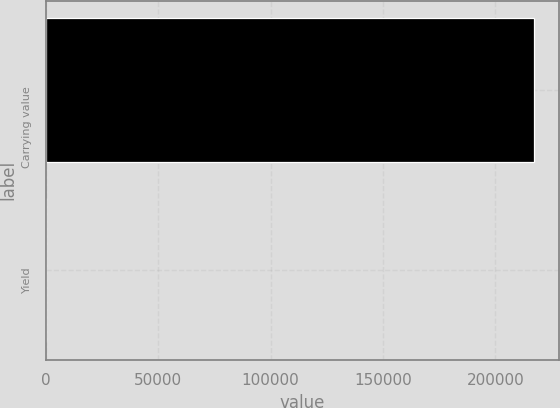Convert chart. <chart><loc_0><loc_0><loc_500><loc_500><bar_chart><fcel>Carrying value<fcel>Yield<nl><fcel>217365<fcel>3.72<nl></chart> 